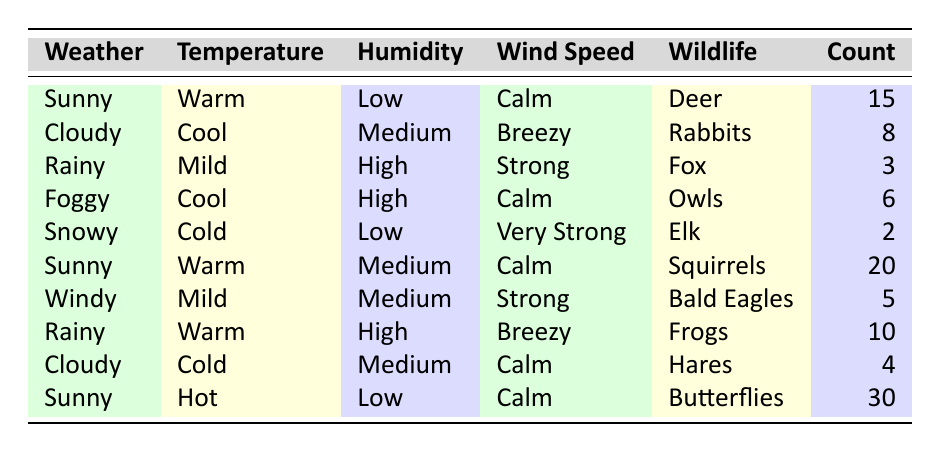What wildlife was sighted on a sunny day with warm temperatures? From the table, the sunny weather conditions with warm temperatures show two wildlife sightings: Deer with a count of 15 and Squirrels with a count of 20.
Answer: Deer, Squirrels How many total sightings were recorded on rainy days? There are two entries for rainy days: 3 sightings of Fox and 10 sightings of Frogs. Summing these gives 3 + 10 = 13.
Answer: 13 Was there any wildlife sighting during snowy weather? In the table, under snowy weather conditions, Elk was sighted with a count of 2. Thus, it is confirmed that there was a wildlife sighting.
Answer: Yes What is the highest wildlife sighting count, and what type of wildlife was it? Reviewing the data, the maximum count is 30, which corresponds to the sighting of Butterflies on a sunny day with hot temperatures.
Answer: 30 Butterflies What is the average wildlife sighting count for cloudy weather conditions? For cloudy weather, there are two entries: Rabbits with 8 sightings and Hares with 4 sightings. To find the average, we sum these counts (8 + 4 = 12) and divide by the number of entries (2). Therefore, the average is 12/2 = 6.
Answer: 6 How many sightings were recorded when the wind speed was strong? In the table, there are two instances of strong wind speed: 3 sightings of Fox under Rainy weather and 5 sightings of Bald Eagles under Windy weather. Adding these gives a total of 3 + 5 = 8 sightings.
Answer: 8 Is there any wildlife that was sighted when the humidity was high? Yes, the table lists two sightings with high humidity: 3 sightings of Fox during Rainy weather and 10 sightings of Frogs during Rainy weather, as well as 6 sightings of Owls during Foggy weather.
Answer: Yes What wildlife sightings occurred during mild temperatures? The table shows that during mild temperatures, there were two sightings: 3 sightings of Fox during Rainy weather and 5 sightings of Bald Eagles during Windy weather.
Answer: Fox, Bald Eagles How many total sightings occurred on sunny days compared to cloudy days? On sunny days, the counts are 15 (Deer), 20 (Squirrels), and 30 (Butterflies), which sums to 15 + 20 + 30 = 65. For cloudy days, the counts are 8 (Rabbits) and 4 (Hares), summing to 8 + 4 = 12. Therefore, there are significantly more sightings on sunny days compared to cloudy days.
Answer: Sunny: 65, Cloudy: 12 